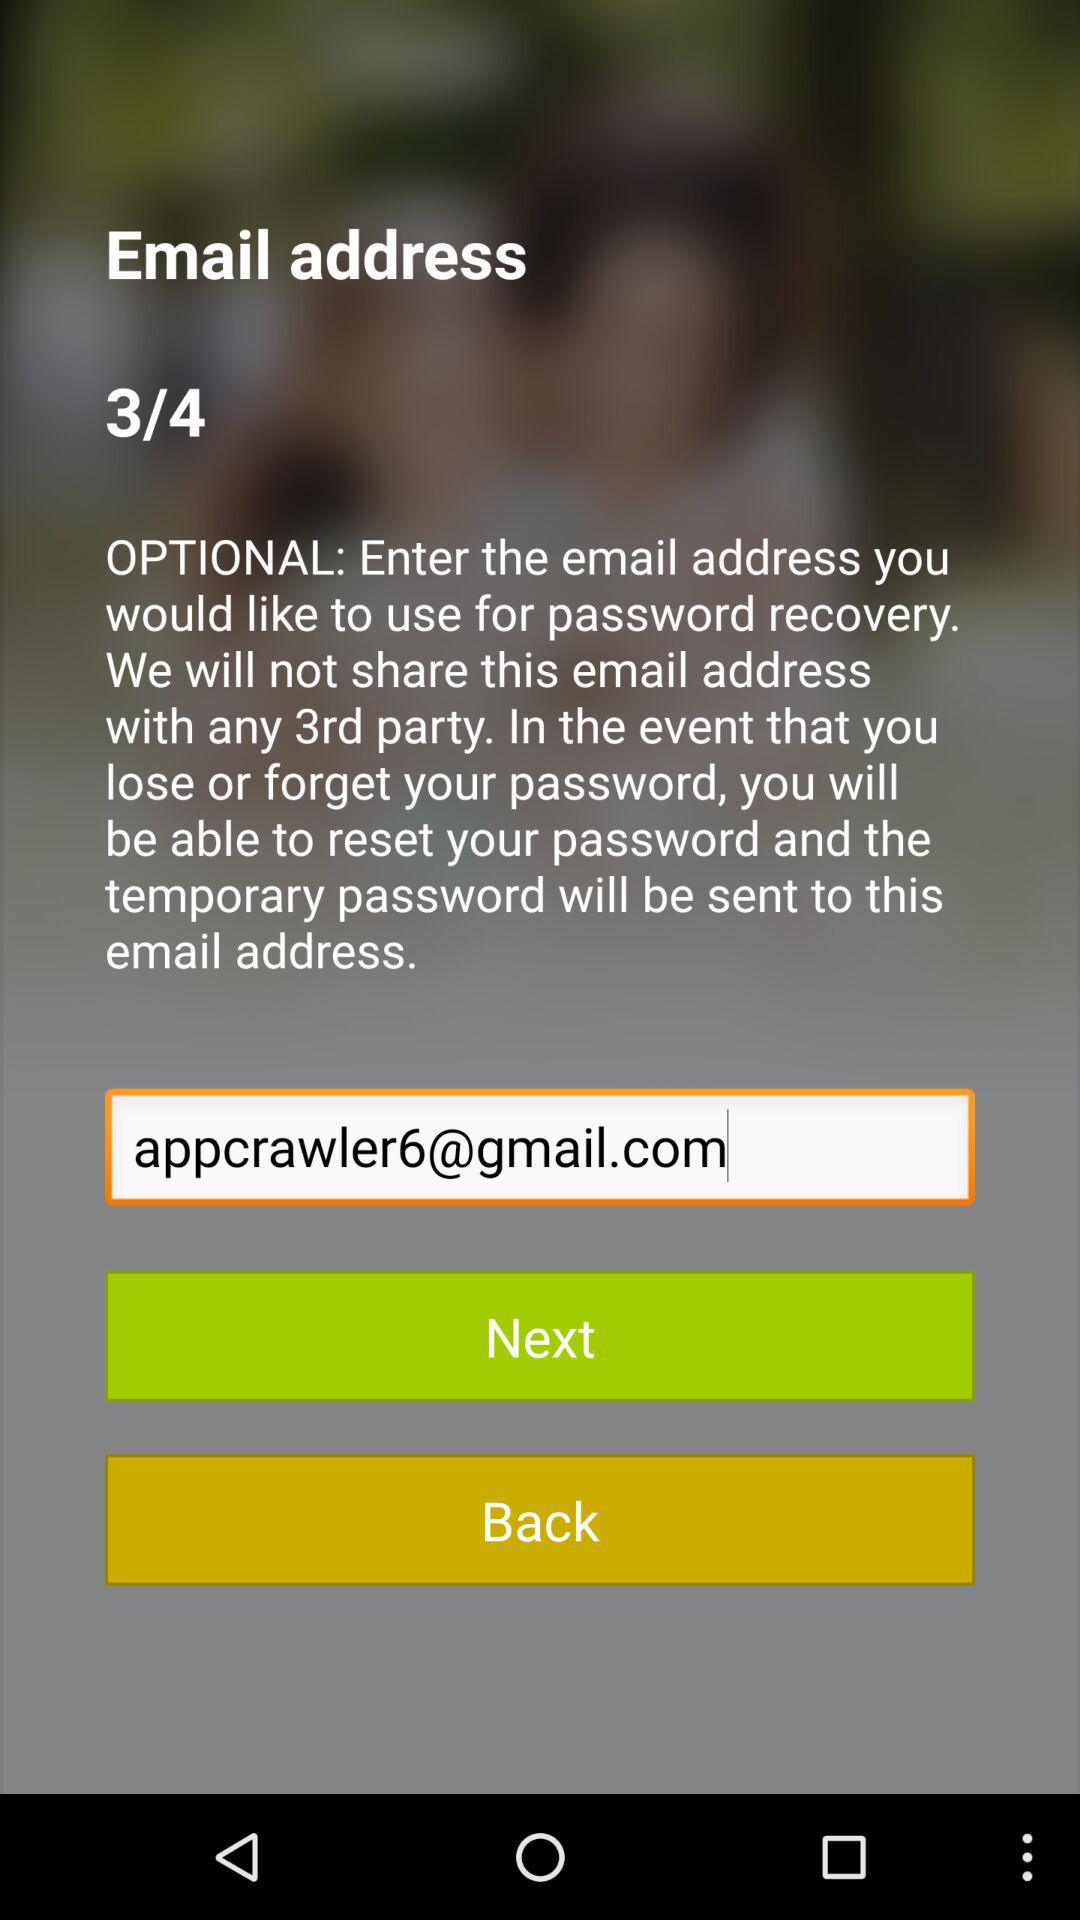How many pages in total are there? There are 4 pages. 